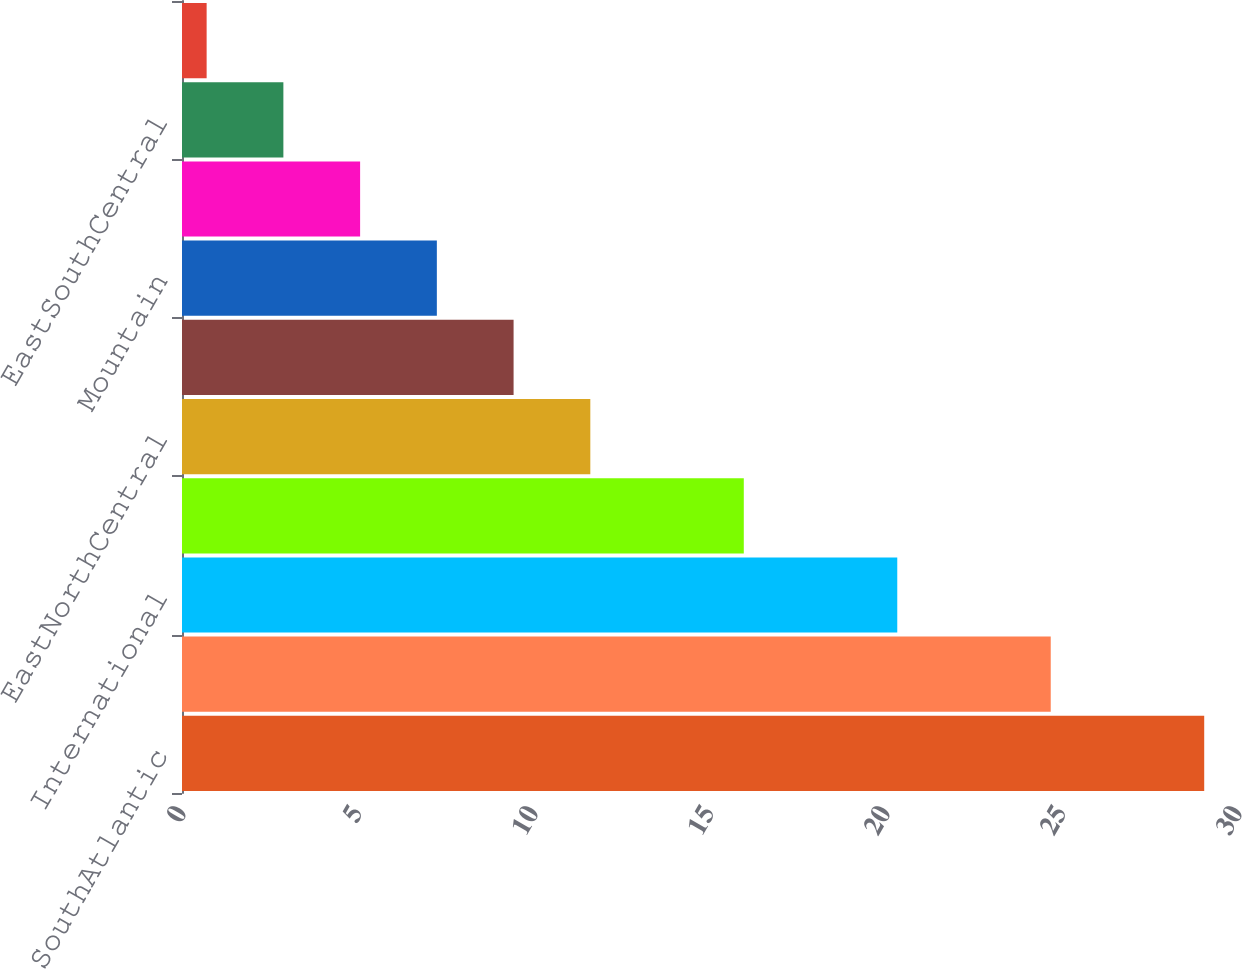Convert chart. <chart><loc_0><loc_0><loc_500><loc_500><bar_chart><fcel>SouthAtlantic<fcel>MiddleAtlantic<fcel>International<fcel>WestSouthCentral<fcel>EastNorthCentral<fcel>NewEngland<fcel>Mountain<fcel>WestNorthCentral<fcel>EastSouthCentral<fcel>Other<nl><fcel>29.04<fcel>24.68<fcel>20.32<fcel>15.96<fcel>11.6<fcel>9.42<fcel>7.24<fcel>5.06<fcel>2.88<fcel>0.7<nl></chart> 